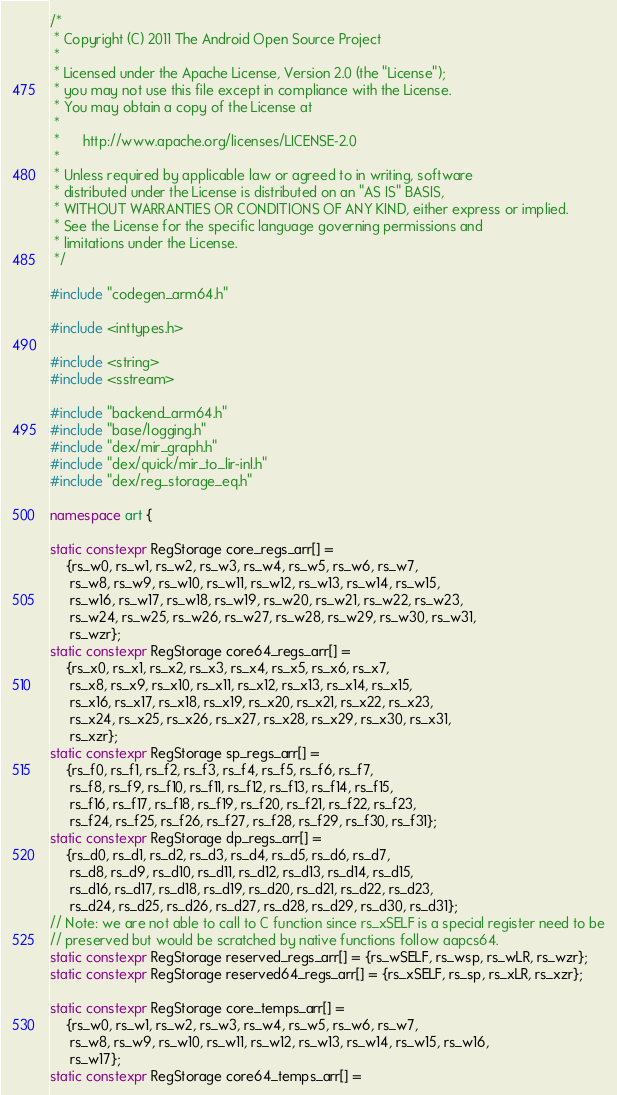<code> <loc_0><loc_0><loc_500><loc_500><_C++_>/*
 * Copyright (C) 2011 The Android Open Source Project
 *
 * Licensed under the Apache License, Version 2.0 (the "License");
 * you may not use this file except in compliance with the License.
 * You may obtain a copy of the License at
 *
 *      http://www.apache.org/licenses/LICENSE-2.0
 *
 * Unless required by applicable law or agreed to in writing, software
 * distributed under the License is distributed on an "AS IS" BASIS,
 * WITHOUT WARRANTIES OR CONDITIONS OF ANY KIND, either express or implied.
 * See the License for the specific language governing permissions and
 * limitations under the License.
 */

#include "codegen_arm64.h"

#include <inttypes.h>

#include <string>
#include <sstream>

#include "backend_arm64.h"
#include "base/logging.h"
#include "dex/mir_graph.h"
#include "dex/quick/mir_to_lir-inl.h"
#include "dex/reg_storage_eq.h"

namespace art {

static constexpr RegStorage core_regs_arr[] =
    {rs_w0, rs_w1, rs_w2, rs_w3, rs_w4, rs_w5, rs_w6, rs_w7,
     rs_w8, rs_w9, rs_w10, rs_w11, rs_w12, rs_w13, rs_w14, rs_w15,
     rs_w16, rs_w17, rs_w18, rs_w19, rs_w20, rs_w21, rs_w22, rs_w23,
     rs_w24, rs_w25, rs_w26, rs_w27, rs_w28, rs_w29, rs_w30, rs_w31,
     rs_wzr};
static constexpr RegStorage core64_regs_arr[] =
    {rs_x0, rs_x1, rs_x2, rs_x3, rs_x4, rs_x5, rs_x6, rs_x7,
     rs_x8, rs_x9, rs_x10, rs_x11, rs_x12, rs_x13, rs_x14, rs_x15,
     rs_x16, rs_x17, rs_x18, rs_x19, rs_x20, rs_x21, rs_x22, rs_x23,
     rs_x24, rs_x25, rs_x26, rs_x27, rs_x28, rs_x29, rs_x30, rs_x31,
     rs_xzr};
static constexpr RegStorage sp_regs_arr[] =
    {rs_f0, rs_f1, rs_f2, rs_f3, rs_f4, rs_f5, rs_f6, rs_f7,
     rs_f8, rs_f9, rs_f10, rs_f11, rs_f12, rs_f13, rs_f14, rs_f15,
     rs_f16, rs_f17, rs_f18, rs_f19, rs_f20, rs_f21, rs_f22, rs_f23,
     rs_f24, rs_f25, rs_f26, rs_f27, rs_f28, rs_f29, rs_f30, rs_f31};
static constexpr RegStorage dp_regs_arr[] =
    {rs_d0, rs_d1, rs_d2, rs_d3, rs_d4, rs_d5, rs_d6, rs_d7,
     rs_d8, rs_d9, rs_d10, rs_d11, rs_d12, rs_d13, rs_d14, rs_d15,
     rs_d16, rs_d17, rs_d18, rs_d19, rs_d20, rs_d21, rs_d22, rs_d23,
     rs_d24, rs_d25, rs_d26, rs_d27, rs_d28, rs_d29, rs_d30, rs_d31};
// Note: we are not able to call to C function since rs_xSELF is a special register need to be
// preserved but would be scratched by native functions follow aapcs64.
static constexpr RegStorage reserved_regs_arr[] = {rs_wSELF, rs_wsp, rs_wLR, rs_wzr};
static constexpr RegStorage reserved64_regs_arr[] = {rs_xSELF, rs_sp, rs_xLR, rs_xzr};

static constexpr RegStorage core_temps_arr[] =
    {rs_w0, rs_w1, rs_w2, rs_w3, rs_w4, rs_w5, rs_w6, rs_w7,
     rs_w8, rs_w9, rs_w10, rs_w11, rs_w12, rs_w13, rs_w14, rs_w15, rs_w16,
     rs_w17};
static constexpr RegStorage core64_temps_arr[] =</code> 